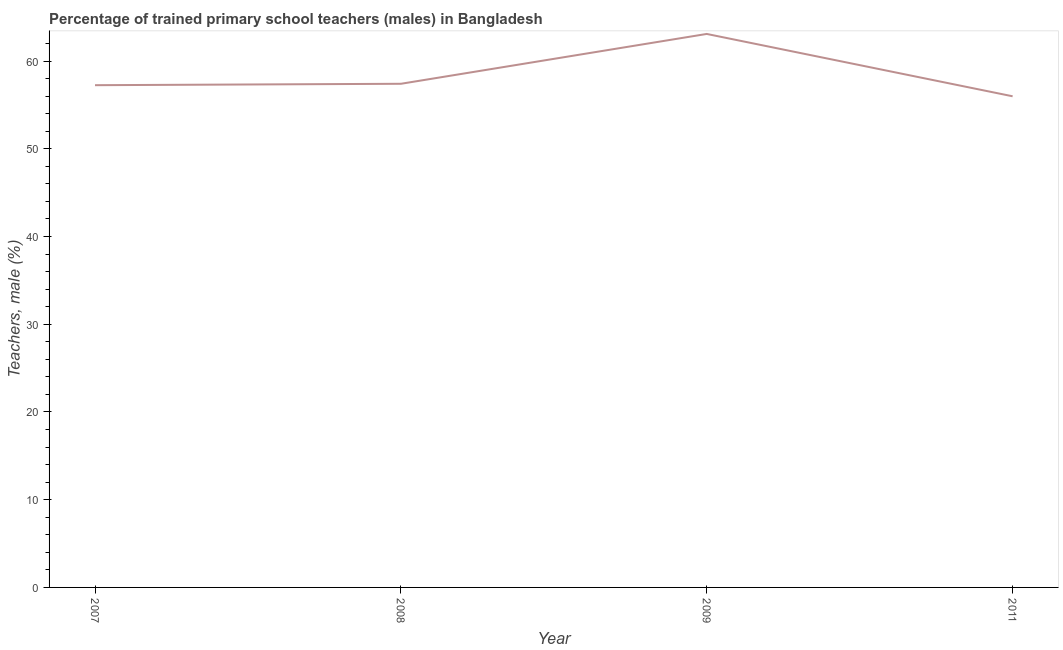What is the percentage of trained male teachers in 2011?
Provide a succinct answer. 55.98. Across all years, what is the maximum percentage of trained male teachers?
Offer a very short reply. 63.09. Across all years, what is the minimum percentage of trained male teachers?
Your response must be concise. 55.98. In which year was the percentage of trained male teachers maximum?
Your answer should be very brief. 2009. In which year was the percentage of trained male teachers minimum?
Give a very brief answer. 2011. What is the sum of the percentage of trained male teachers?
Your answer should be very brief. 233.73. What is the difference between the percentage of trained male teachers in 2007 and 2008?
Offer a terse response. -0.16. What is the average percentage of trained male teachers per year?
Offer a very short reply. 58.43. What is the median percentage of trained male teachers?
Your answer should be compact. 57.33. In how many years, is the percentage of trained male teachers greater than 38 %?
Provide a short and direct response. 4. What is the ratio of the percentage of trained male teachers in 2007 to that in 2011?
Keep it short and to the point. 1.02. What is the difference between the highest and the second highest percentage of trained male teachers?
Ensure brevity in your answer.  5.68. Is the sum of the percentage of trained male teachers in 2009 and 2011 greater than the maximum percentage of trained male teachers across all years?
Provide a succinct answer. Yes. What is the difference between the highest and the lowest percentage of trained male teachers?
Ensure brevity in your answer.  7.11. Does the percentage of trained male teachers monotonically increase over the years?
Provide a short and direct response. No. How many years are there in the graph?
Your response must be concise. 4. What is the difference between two consecutive major ticks on the Y-axis?
Offer a very short reply. 10. Are the values on the major ticks of Y-axis written in scientific E-notation?
Offer a terse response. No. Does the graph contain any zero values?
Keep it short and to the point. No. What is the title of the graph?
Keep it short and to the point. Percentage of trained primary school teachers (males) in Bangladesh. What is the label or title of the X-axis?
Provide a short and direct response. Year. What is the label or title of the Y-axis?
Your response must be concise. Teachers, male (%). What is the Teachers, male (%) of 2007?
Keep it short and to the point. 57.25. What is the Teachers, male (%) in 2008?
Keep it short and to the point. 57.41. What is the Teachers, male (%) in 2009?
Provide a short and direct response. 63.09. What is the Teachers, male (%) in 2011?
Make the answer very short. 55.98. What is the difference between the Teachers, male (%) in 2007 and 2008?
Your answer should be compact. -0.16. What is the difference between the Teachers, male (%) in 2007 and 2009?
Your response must be concise. -5.84. What is the difference between the Teachers, male (%) in 2007 and 2011?
Keep it short and to the point. 1.26. What is the difference between the Teachers, male (%) in 2008 and 2009?
Your answer should be compact. -5.68. What is the difference between the Teachers, male (%) in 2008 and 2011?
Offer a terse response. 1.42. What is the difference between the Teachers, male (%) in 2009 and 2011?
Ensure brevity in your answer.  7.11. What is the ratio of the Teachers, male (%) in 2007 to that in 2008?
Offer a terse response. 1. What is the ratio of the Teachers, male (%) in 2007 to that in 2009?
Provide a short and direct response. 0.91. What is the ratio of the Teachers, male (%) in 2007 to that in 2011?
Your response must be concise. 1.02. What is the ratio of the Teachers, male (%) in 2008 to that in 2009?
Your response must be concise. 0.91. What is the ratio of the Teachers, male (%) in 2009 to that in 2011?
Provide a succinct answer. 1.13. 